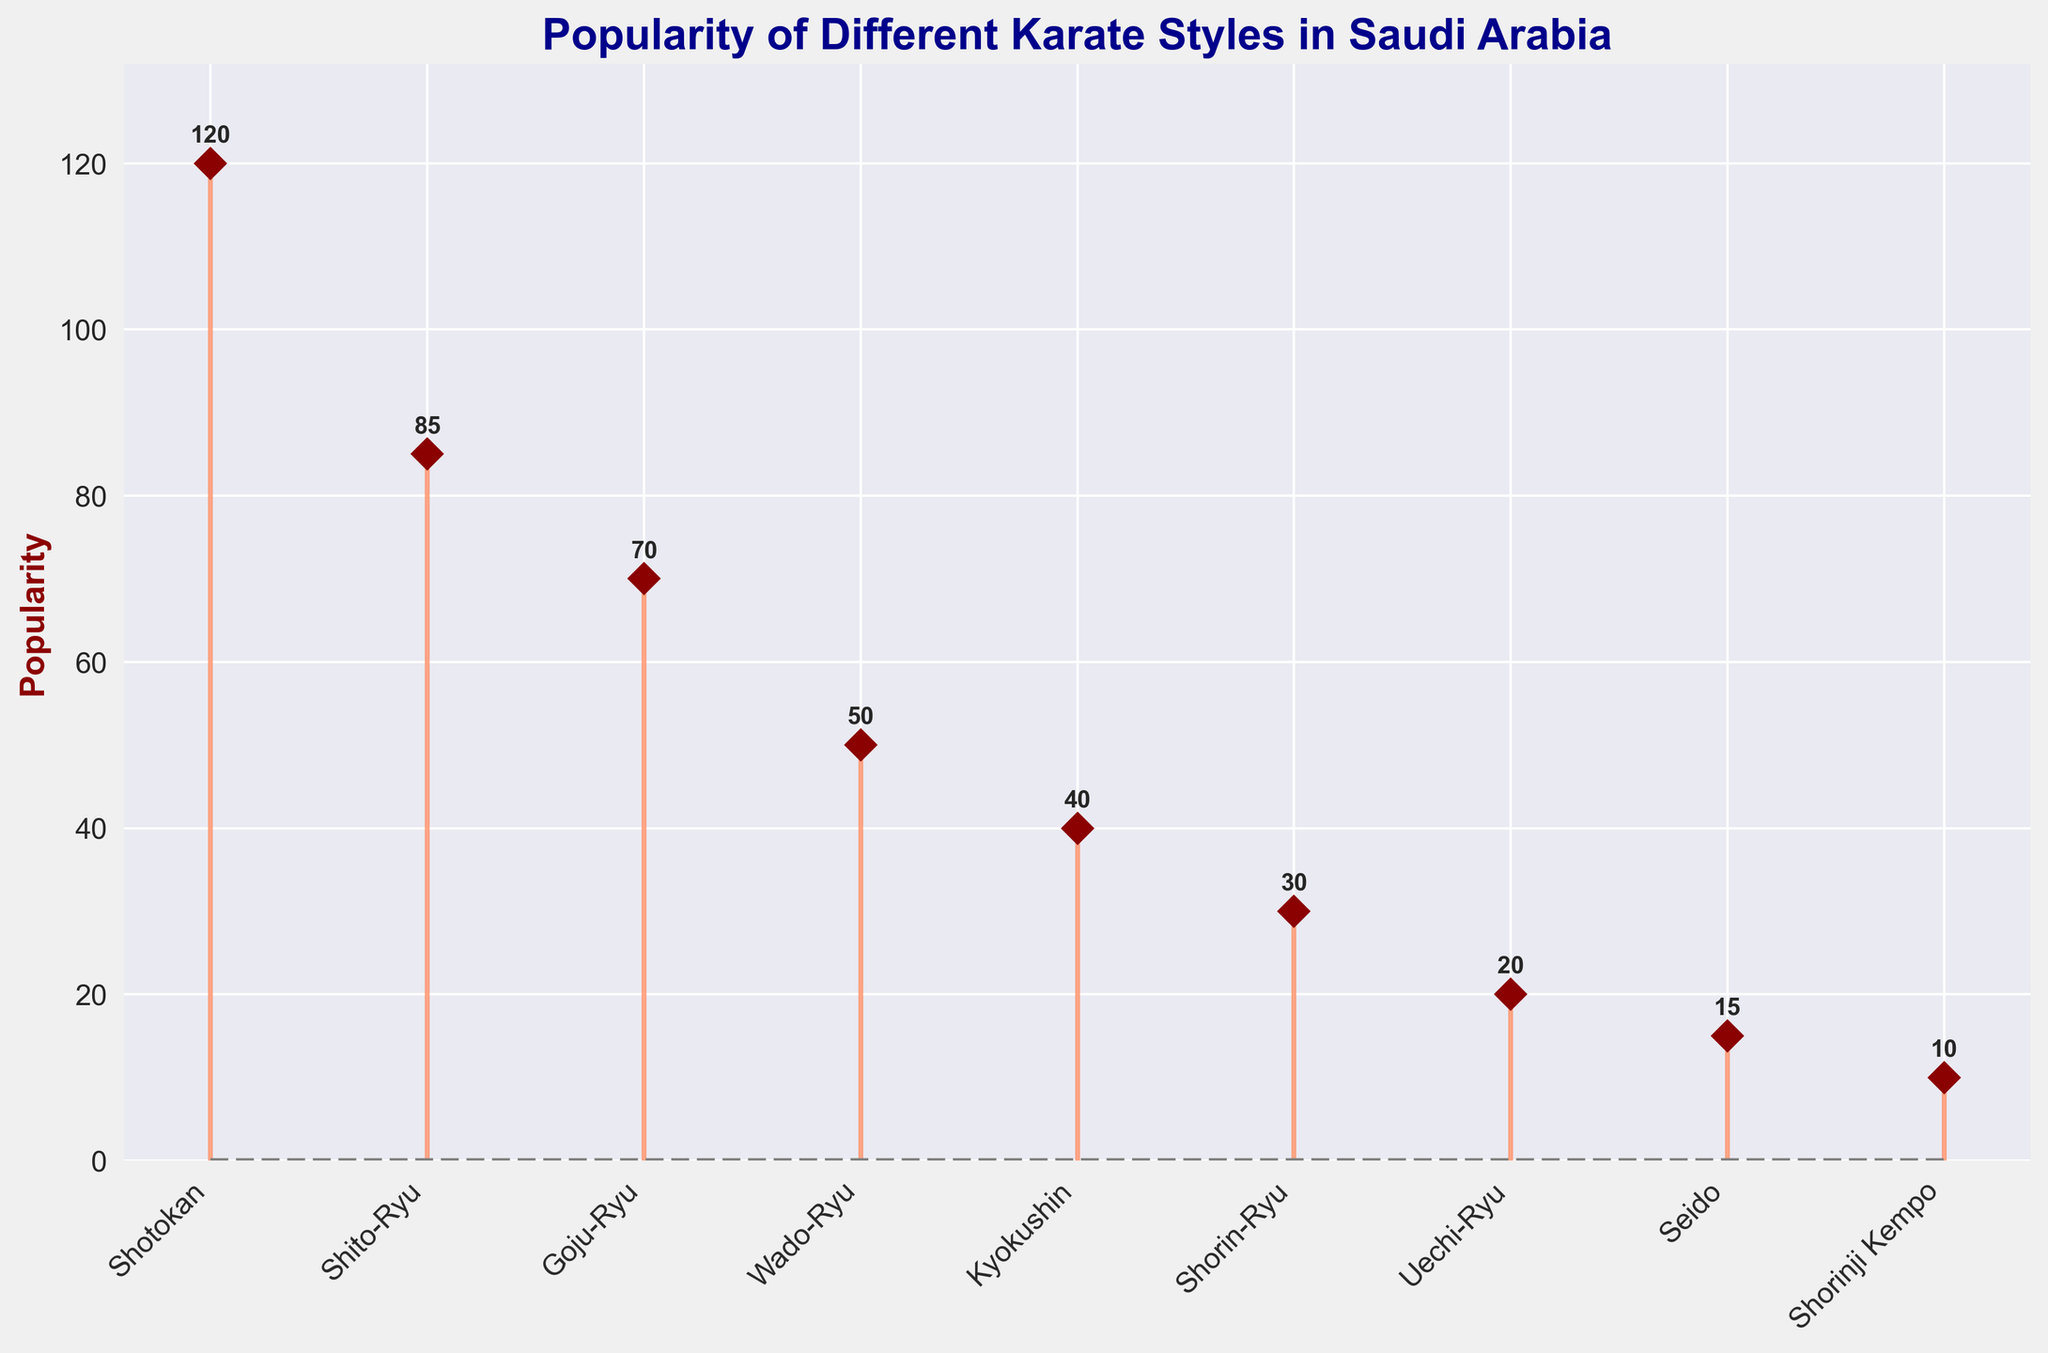What's the title of the plot? The title of the plot is displayed at the top of the figure in bold and large font size. It reads: "Popularity of Different Karate Styles in Saudi Arabia".
Answer: Popularity of Different Karate Styles in Saudi Arabia How many karate styles are shown in the plot? The stem plot displays data points for each karate style on the x-axis, represented by 9 different names.
Answer: 9 Which karate style is the least popular? The least popular karate style will have the lowest value in the stem plot. Shorinji Kempo corresponds to the smallest marker and stem.
Answer: Shorinji Kempo What is the popularity of Shotokan? The popularity of Shotokan is denoted by the height of its stem and the number next to it, which reads 120.
Answer: 120 What is the combined popularity of Shito-Ryu and Goju-Ryu? Add the popularity values of Shito-Ryu (85) and Goju-Ryu (70). The sum is 85 + 70 = 155.
Answer: 155 How many karate styles have a popularity greater than 50? Count the number of karate styles whose popularity values are greater than 50. These are Shotokan (120), Shito-Ryu (85), and Goju-Ryu (70).
Answer: 3 Which karate style has a popularity exactly halfway between that of Goju-Ryu and Shorin-Ryu? Find the midpoint between Goju-Ryu (70) and Shorin-Ryu (30): (70 + 30)/2 = 50. Wado-Ryu has this popularity.
Answer: Wado-Ryu What is the difference in popularity between Kyokushin and Shorinji Kempo? Subtract the popularity of Shorinji Kempo (10) from Kyokushin (40). 40 - 10 = 30.
Answer: 30 What are the colors used for the marker lines and the baseline? The marker lines are set in coral color, and the baseline is gray with a dashed linestyle.
Answer: coral and gray What is the average popularity of all the karate styles depicted in the plot? Add the popularity values of all styles and divide by the number of styles: (120 + 85 + 70 + 50 + 40 + 30 + 20 + 15 + 10) / 9 = 49.
Answer: 49 